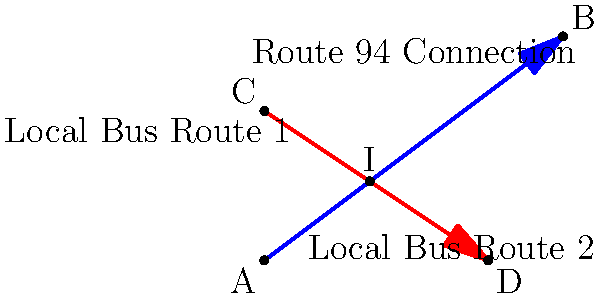Two local bus routes in Sunderland intersect at a point where they both connect to Route 94. The first route can be represented by the line equation $y = \frac{3}{4}x + 4$, and the second route by the equation $y = -\frac{2}{3}x + 4$. At which point $(x, y)$ do these bus routes intersect? To find the intersection point of the two lines, we need to solve the system of equations:

1) $y = \frac{3}{4}x + 4$ (Line 1)
2) $y = -\frac{2}{3}x + 4$ (Line 2)

At the intersection point, the $y$ values will be equal, so we can set the right sides of the equations equal to each other:

3) $\frac{3}{4}x + 4 = -\frac{2}{3}x + 4$

Now, let's solve for $x$:

4) $\frac{3}{4}x + \frac{2}{3}x = 0$
5) $\frac{9}{12}x + \frac{8}{12}x = 0$ (finding a common denominator)
6) $\frac{17}{12}x = 0$
7) $x = 0$

Now that we know $x = 0$, we can substitute this value into either of the original equations to find $y$. Let's use the first equation:

8) $y = \frac{3}{4}(0) + 4 = 4$

Therefore, the intersection point is $(0, 4)$.
Answer: $(0, 4)$ 